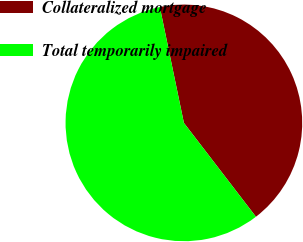Convert chart. <chart><loc_0><loc_0><loc_500><loc_500><pie_chart><fcel>Collateralized mortgage<fcel>Total temporarily impaired<nl><fcel>42.84%<fcel>57.16%<nl></chart> 